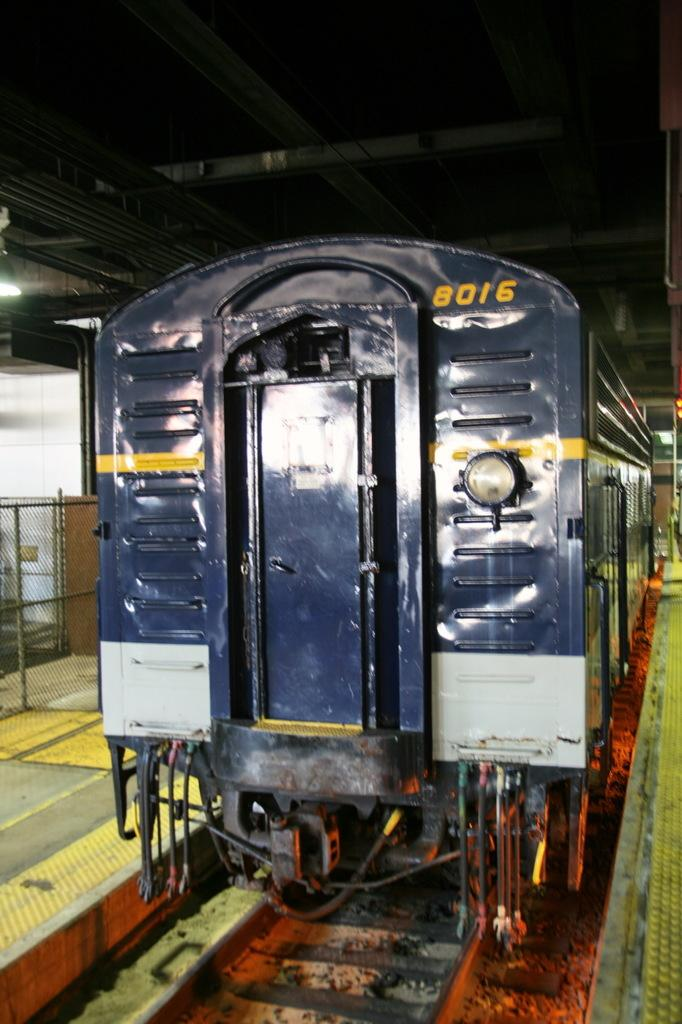What is the main subject of the image? The main subject of the image is a train. Where is the train located in the image? The train is in the center of the image. What is the train positioned on? The train is on railway tracks. What can be seen on both sides of the train in the image? There are platforms on both the right and left sides of the image. What type of eggnog is being served on the platforms in the image? There is no eggnog present in the image; it features a train on railway tracks with platforms on both sides. Who is the creator of the train depicted in the image? The creator of the train is not mentioned or visible in the image. 